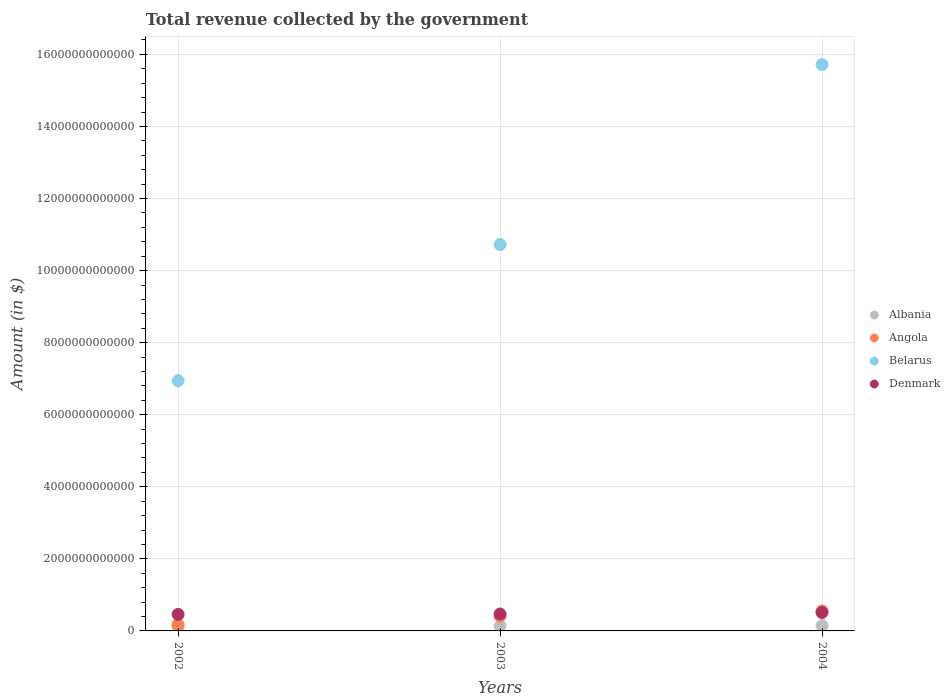Is the number of dotlines equal to the number of legend labels?
Ensure brevity in your answer.  Yes. What is the total revenue collected by the government in Belarus in 2004?
Ensure brevity in your answer.  1.57e+13. Across all years, what is the maximum total revenue collected by the government in Belarus?
Ensure brevity in your answer.  1.57e+13. Across all years, what is the minimum total revenue collected by the government in Belarus?
Make the answer very short. 6.94e+12. In which year was the total revenue collected by the government in Belarus maximum?
Your response must be concise. 2004. What is the total total revenue collected by the government in Denmark in the graph?
Give a very brief answer. 1.44e+12. What is the difference between the total revenue collected by the government in Albania in 2002 and that in 2004?
Your response must be concise. -2.71e+1. What is the difference between the total revenue collected by the government in Albania in 2004 and the total revenue collected by the government in Belarus in 2002?
Provide a succinct answer. -6.80e+12. What is the average total revenue collected by the government in Belarus per year?
Make the answer very short. 1.11e+13. In the year 2003, what is the difference between the total revenue collected by the government in Angola and total revenue collected by the government in Belarus?
Provide a short and direct response. -1.03e+13. What is the ratio of the total revenue collected by the government in Denmark in 2003 to that in 2004?
Provide a short and direct response. 0.92. What is the difference between the highest and the second highest total revenue collected by the government in Denmark?
Provide a succinct answer. 4.27e+1. What is the difference between the highest and the lowest total revenue collected by the government in Belarus?
Your answer should be very brief. 8.77e+12. In how many years, is the total revenue collected by the government in Belarus greater than the average total revenue collected by the government in Belarus taken over all years?
Provide a short and direct response. 1. Is it the case that in every year, the sum of the total revenue collected by the government in Belarus and total revenue collected by the government in Albania  is greater than the sum of total revenue collected by the government in Denmark and total revenue collected by the government in Angola?
Your response must be concise. No. Is it the case that in every year, the sum of the total revenue collected by the government in Denmark and total revenue collected by the government in Angola  is greater than the total revenue collected by the government in Albania?
Give a very brief answer. Yes. Does the total revenue collected by the government in Denmark monotonically increase over the years?
Make the answer very short. Yes. Is the total revenue collected by the government in Belarus strictly less than the total revenue collected by the government in Angola over the years?
Your answer should be compact. No. How many dotlines are there?
Offer a very short reply. 4. How many years are there in the graph?
Provide a succinct answer. 3. What is the difference between two consecutive major ticks on the Y-axis?
Your response must be concise. 2.00e+12. Are the values on the major ticks of Y-axis written in scientific E-notation?
Give a very brief answer. No. What is the title of the graph?
Give a very brief answer. Total revenue collected by the government. Does "Brunei Darussalam" appear as one of the legend labels in the graph?
Your answer should be very brief. No. What is the label or title of the Y-axis?
Provide a succinct answer. Amount (in $). What is the Amount (in $) of Albania in 2002?
Your answer should be compact. 1.21e+11. What is the Amount (in $) in Angola in 2002?
Give a very brief answer. 1.77e+11. What is the Amount (in $) in Belarus in 2002?
Offer a terse response. 6.94e+12. What is the Amount (in $) in Denmark in 2002?
Make the answer very short. 4.58e+11. What is the Amount (in $) in Albania in 2003?
Your answer should be compact. 1.36e+11. What is the Amount (in $) in Angola in 2003?
Keep it short and to the point. 4.10e+11. What is the Amount (in $) in Belarus in 2003?
Ensure brevity in your answer.  1.07e+13. What is the Amount (in $) in Denmark in 2003?
Give a very brief answer. 4.69e+11. What is the Amount (in $) in Albania in 2004?
Keep it short and to the point. 1.48e+11. What is the Amount (in $) of Angola in 2004?
Provide a short and direct response. 5.55e+11. What is the Amount (in $) of Belarus in 2004?
Ensure brevity in your answer.  1.57e+13. What is the Amount (in $) in Denmark in 2004?
Ensure brevity in your answer.  5.12e+11. Across all years, what is the maximum Amount (in $) in Albania?
Make the answer very short. 1.48e+11. Across all years, what is the maximum Amount (in $) in Angola?
Ensure brevity in your answer.  5.55e+11. Across all years, what is the maximum Amount (in $) of Belarus?
Your answer should be compact. 1.57e+13. Across all years, what is the maximum Amount (in $) in Denmark?
Provide a succinct answer. 5.12e+11. Across all years, what is the minimum Amount (in $) of Albania?
Keep it short and to the point. 1.21e+11. Across all years, what is the minimum Amount (in $) in Angola?
Offer a very short reply. 1.77e+11. Across all years, what is the minimum Amount (in $) in Belarus?
Make the answer very short. 6.94e+12. Across all years, what is the minimum Amount (in $) of Denmark?
Keep it short and to the point. 4.58e+11. What is the total Amount (in $) in Albania in the graph?
Make the answer very short. 4.04e+11. What is the total Amount (in $) of Angola in the graph?
Ensure brevity in your answer.  1.14e+12. What is the total Amount (in $) of Belarus in the graph?
Provide a short and direct response. 3.34e+13. What is the total Amount (in $) of Denmark in the graph?
Give a very brief answer. 1.44e+12. What is the difference between the Amount (in $) of Albania in 2002 and that in 2003?
Provide a succinct answer. -1.49e+1. What is the difference between the Amount (in $) of Angola in 2002 and that in 2003?
Your response must be concise. -2.32e+11. What is the difference between the Amount (in $) of Belarus in 2002 and that in 2003?
Make the answer very short. -3.78e+12. What is the difference between the Amount (in $) of Denmark in 2002 and that in 2003?
Give a very brief answer. -1.08e+1. What is the difference between the Amount (in $) in Albania in 2002 and that in 2004?
Your answer should be compact. -2.71e+1. What is the difference between the Amount (in $) in Angola in 2002 and that in 2004?
Offer a terse response. -3.78e+11. What is the difference between the Amount (in $) in Belarus in 2002 and that in 2004?
Provide a short and direct response. -8.77e+12. What is the difference between the Amount (in $) in Denmark in 2002 and that in 2004?
Ensure brevity in your answer.  -5.36e+1. What is the difference between the Amount (in $) of Albania in 2003 and that in 2004?
Make the answer very short. -1.22e+1. What is the difference between the Amount (in $) of Angola in 2003 and that in 2004?
Your answer should be very brief. -1.45e+11. What is the difference between the Amount (in $) of Belarus in 2003 and that in 2004?
Make the answer very short. -4.99e+12. What is the difference between the Amount (in $) of Denmark in 2003 and that in 2004?
Provide a succinct answer. -4.27e+1. What is the difference between the Amount (in $) in Albania in 2002 and the Amount (in $) in Angola in 2003?
Your response must be concise. -2.89e+11. What is the difference between the Amount (in $) of Albania in 2002 and the Amount (in $) of Belarus in 2003?
Make the answer very short. -1.06e+13. What is the difference between the Amount (in $) in Albania in 2002 and the Amount (in $) in Denmark in 2003?
Offer a very short reply. -3.48e+11. What is the difference between the Amount (in $) of Angola in 2002 and the Amount (in $) of Belarus in 2003?
Provide a succinct answer. -1.05e+13. What is the difference between the Amount (in $) of Angola in 2002 and the Amount (in $) of Denmark in 2003?
Provide a succinct answer. -2.92e+11. What is the difference between the Amount (in $) in Belarus in 2002 and the Amount (in $) in Denmark in 2003?
Offer a very short reply. 6.48e+12. What is the difference between the Amount (in $) of Albania in 2002 and the Amount (in $) of Angola in 2004?
Your answer should be compact. -4.34e+11. What is the difference between the Amount (in $) in Albania in 2002 and the Amount (in $) in Belarus in 2004?
Your answer should be very brief. -1.56e+13. What is the difference between the Amount (in $) of Albania in 2002 and the Amount (in $) of Denmark in 2004?
Provide a short and direct response. -3.91e+11. What is the difference between the Amount (in $) in Angola in 2002 and the Amount (in $) in Belarus in 2004?
Your answer should be compact. -1.55e+13. What is the difference between the Amount (in $) in Angola in 2002 and the Amount (in $) in Denmark in 2004?
Your response must be concise. -3.35e+11. What is the difference between the Amount (in $) in Belarus in 2002 and the Amount (in $) in Denmark in 2004?
Ensure brevity in your answer.  6.43e+12. What is the difference between the Amount (in $) of Albania in 2003 and the Amount (in $) of Angola in 2004?
Provide a short and direct response. -4.19e+11. What is the difference between the Amount (in $) in Albania in 2003 and the Amount (in $) in Belarus in 2004?
Offer a terse response. -1.56e+13. What is the difference between the Amount (in $) of Albania in 2003 and the Amount (in $) of Denmark in 2004?
Your response must be concise. -3.76e+11. What is the difference between the Amount (in $) of Angola in 2003 and the Amount (in $) of Belarus in 2004?
Ensure brevity in your answer.  -1.53e+13. What is the difference between the Amount (in $) of Angola in 2003 and the Amount (in $) of Denmark in 2004?
Keep it short and to the point. -1.02e+11. What is the difference between the Amount (in $) of Belarus in 2003 and the Amount (in $) of Denmark in 2004?
Your answer should be compact. 1.02e+13. What is the average Amount (in $) of Albania per year?
Ensure brevity in your answer.  1.35e+11. What is the average Amount (in $) in Angola per year?
Your answer should be compact. 3.80e+11. What is the average Amount (in $) in Belarus per year?
Provide a succinct answer. 1.11e+13. What is the average Amount (in $) in Denmark per year?
Your answer should be very brief. 4.80e+11. In the year 2002, what is the difference between the Amount (in $) of Albania and Amount (in $) of Angola?
Ensure brevity in your answer.  -5.64e+1. In the year 2002, what is the difference between the Amount (in $) in Albania and Amount (in $) in Belarus?
Offer a very short reply. -6.82e+12. In the year 2002, what is the difference between the Amount (in $) in Albania and Amount (in $) in Denmark?
Offer a very short reply. -3.37e+11. In the year 2002, what is the difference between the Amount (in $) of Angola and Amount (in $) of Belarus?
Your response must be concise. -6.77e+12. In the year 2002, what is the difference between the Amount (in $) in Angola and Amount (in $) in Denmark?
Keep it short and to the point. -2.81e+11. In the year 2002, what is the difference between the Amount (in $) in Belarus and Amount (in $) in Denmark?
Provide a succinct answer. 6.49e+12. In the year 2003, what is the difference between the Amount (in $) in Albania and Amount (in $) in Angola?
Give a very brief answer. -2.74e+11. In the year 2003, what is the difference between the Amount (in $) of Albania and Amount (in $) of Belarus?
Offer a very short reply. -1.06e+13. In the year 2003, what is the difference between the Amount (in $) of Albania and Amount (in $) of Denmark?
Offer a terse response. -3.33e+11. In the year 2003, what is the difference between the Amount (in $) in Angola and Amount (in $) in Belarus?
Make the answer very short. -1.03e+13. In the year 2003, what is the difference between the Amount (in $) in Angola and Amount (in $) in Denmark?
Offer a very short reply. -5.94e+1. In the year 2003, what is the difference between the Amount (in $) in Belarus and Amount (in $) in Denmark?
Your answer should be very brief. 1.03e+13. In the year 2004, what is the difference between the Amount (in $) of Albania and Amount (in $) of Angola?
Your answer should be very brief. -4.07e+11. In the year 2004, what is the difference between the Amount (in $) in Albania and Amount (in $) in Belarus?
Provide a succinct answer. -1.56e+13. In the year 2004, what is the difference between the Amount (in $) of Albania and Amount (in $) of Denmark?
Your answer should be compact. -3.64e+11. In the year 2004, what is the difference between the Amount (in $) in Angola and Amount (in $) in Belarus?
Give a very brief answer. -1.52e+13. In the year 2004, what is the difference between the Amount (in $) in Angola and Amount (in $) in Denmark?
Provide a short and direct response. 4.31e+1. In the year 2004, what is the difference between the Amount (in $) of Belarus and Amount (in $) of Denmark?
Make the answer very short. 1.52e+13. What is the ratio of the Amount (in $) of Albania in 2002 to that in 2003?
Ensure brevity in your answer.  0.89. What is the ratio of the Amount (in $) in Angola in 2002 to that in 2003?
Provide a short and direct response. 0.43. What is the ratio of the Amount (in $) of Belarus in 2002 to that in 2003?
Give a very brief answer. 0.65. What is the ratio of the Amount (in $) in Albania in 2002 to that in 2004?
Make the answer very short. 0.82. What is the ratio of the Amount (in $) of Angola in 2002 to that in 2004?
Your answer should be compact. 0.32. What is the ratio of the Amount (in $) in Belarus in 2002 to that in 2004?
Your answer should be compact. 0.44. What is the ratio of the Amount (in $) in Denmark in 2002 to that in 2004?
Offer a terse response. 0.9. What is the ratio of the Amount (in $) of Albania in 2003 to that in 2004?
Keep it short and to the point. 0.92. What is the ratio of the Amount (in $) of Angola in 2003 to that in 2004?
Ensure brevity in your answer.  0.74. What is the ratio of the Amount (in $) in Belarus in 2003 to that in 2004?
Ensure brevity in your answer.  0.68. What is the ratio of the Amount (in $) of Denmark in 2003 to that in 2004?
Your answer should be compact. 0.92. What is the difference between the highest and the second highest Amount (in $) in Albania?
Your answer should be very brief. 1.22e+1. What is the difference between the highest and the second highest Amount (in $) of Angola?
Provide a succinct answer. 1.45e+11. What is the difference between the highest and the second highest Amount (in $) of Belarus?
Give a very brief answer. 4.99e+12. What is the difference between the highest and the second highest Amount (in $) in Denmark?
Your answer should be compact. 4.27e+1. What is the difference between the highest and the lowest Amount (in $) in Albania?
Provide a succinct answer. 2.71e+1. What is the difference between the highest and the lowest Amount (in $) in Angola?
Your answer should be very brief. 3.78e+11. What is the difference between the highest and the lowest Amount (in $) in Belarus?
Keep it short and to the point. 8.77e+12. What is the difference between the highest and the lowest Amount (in $) in Denmark?
Offer a terse response. 5.36e+1. 